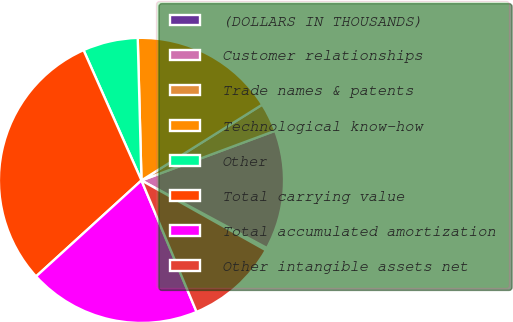Convert chart to OTSL. <chart><loc_0><loc_0><loc_500><loc_500><pie_chart><fcel>(DOLLARS IN THOUSANDS)<fcel>Customer relationships<fcel>Trade names & patents<fcel>Technological know-how<fcel>Other<fcel>Total carrying value<fcel>Total accumulated amortization<fcel>Other intangible assets net<nl><fcel>0.28%<fcel>13.52%<fcel>3.26%<fcel>16.5%<fcel>6.24%<fcel>30.1%<fcel>19.56%<fcel>10.54%<nl></chart> 